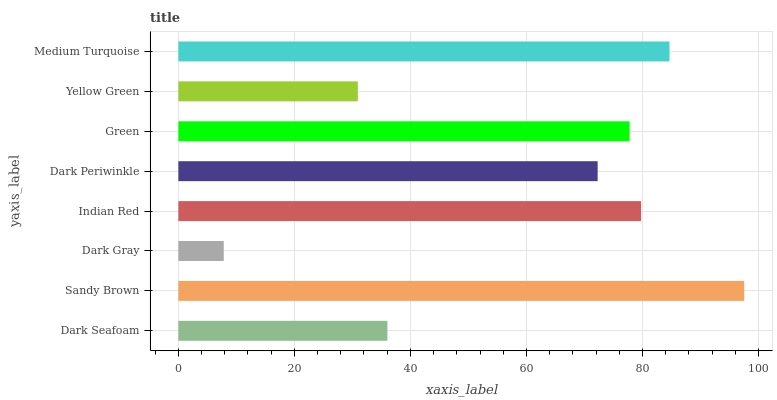Is Dark Gray the minimum?
Answer yes or no. Yes. Is Sandy Brown the maximum?
Answer yes or no. Yes. Is Sandy Brown the minimum?
Answer yes or no. No. Is Dark Gray the maximum?
Answer yes or no. No. Is Sandy Brown greater than Dark Gray?
Answer yes or no. Yes. Is Dark Gray less than Sandy Brown?
Answer yes or no. Yes. Is Dark Gray greater than Sandy Brown?
Answer yes or no. No. Is Sandy Brown less than Dark Gray?
Answer yes or no. No. Is Green the high median?
Answer yes or no. Yes. Is Dark Periwinkle the low median?
Answer yes or no. Yes. Is Dark Seafoam the high median?
Answer yes or no. No. Is Dark Seafoam the low median?
Answer yes or no. No. 